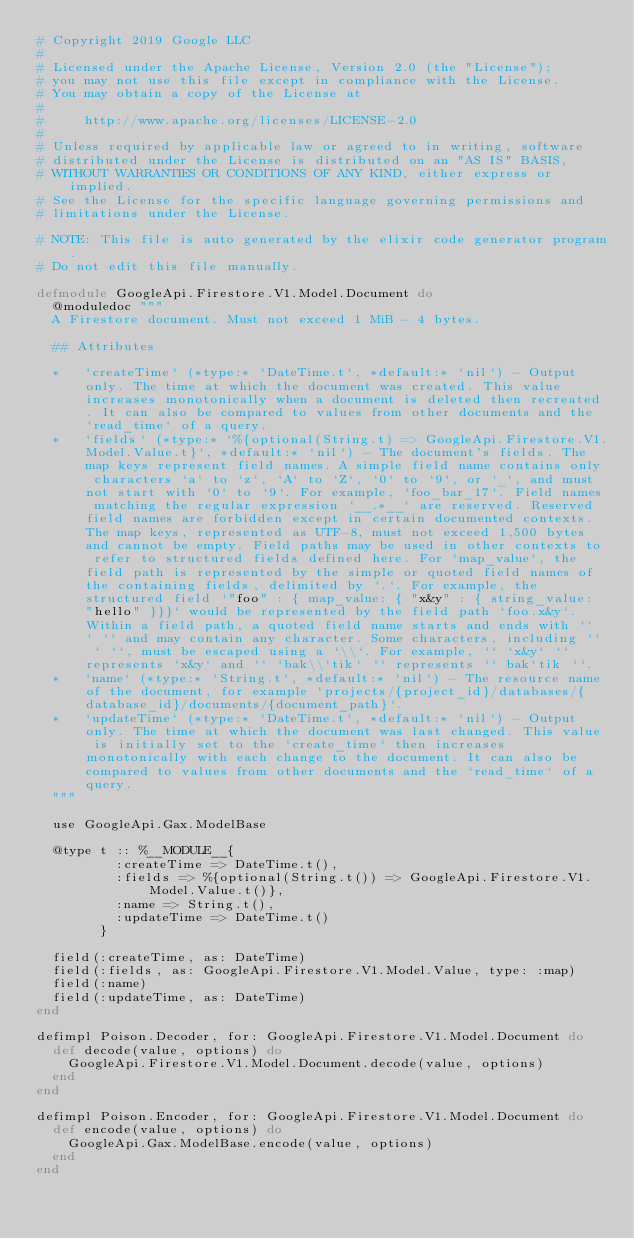Convert code to text. <code><loc_0><loc_0><loc_500><loc_500><_Elixir_># Copyright 2019 Google LLC
#
# Licensed under the Apache License, Version 2.0 (the "License");
# you may not use this file except in compliance with the License.
# You may obtain a copy of the License at
#
#     http://www.apache.org/licenses/LICENSE-2.0
#
# Unless required by applicable law or agreed to in writing, software
# distributed under the License is distributed on an "AS IS" BASIS,
# WITHOUT WARRANTIES OR CONDITIONS OF ANY KIND, either express or implied.
# See the License for the specific language governing permissions and
# limitations under the License.

# NOTE: This file is auto generated by the elixir code generator program.
# Do not edit this file manually.

defmodule GoogleApi.Firestore.V1.Model.Document do
  @moduledoc """
  A Firestore document. Must not exceed 1 MiB - 4 bytes.

  ## Attributes

  *   `createTime` (*type:* `DateTime.t`, *default:* `nil`) - Output only. The time at which the document was created. This value increases monotonically when a document is deleted then recreated. It can also be compared to values from other documents and the `read_time` of a query.
  *   `fields` (*type:* `%{optional(String.t) => GoogleApi.Firestore.V1.Model.Value.t}`, *default:* `nil`) - The document's fields. The map keys represent field names. A simple field name contains only characters `a` to `z`, `A` to `Z`, `0` to `9`, or `_`, and must not start with `0` to `9`. For example, `foo_bar_17`. Field names matching the regular expression `__.*__` are reserved. Reserved field names are forbidden except in certain documented contexts. The map keys, represented as UTF-8, must not exceed 1,500 bytes and cannot be empty. Field paths may be used in other contexts to refer to structured fields defined here. For `map_value`, the field path is represented by the simple or quoted field names of the containing fields, delimited by `.`. For example, the structured field `"foo" : { map_value: { "x&y" : { string_value: "hello" }}}` would be represented by the field path `foo.x&y`. Within a field path, a quoted field name starts and ends with `` ` `` and may contain any character. Some characters, including `` ` ``, must be escaped using a `\\`. For example, `` `x&y` `` represents `x&y` and `` `bak\\`tik` `` represents `` bak`tik ``.
  *   `name` (*type:* `String.t`, *default:* `nil`) - The resource name of the document, for example `projects/{project_id}/databases/{database_id}/documents/{document_path}`.
  *   `updateTime` (*type:* `DateTime.t`, *default:* `nil`) - Output only. The time at which the document was last changed. This value is initially set to the `create_time` then increases monotonically with each change to the document. It can also be compared to values from other documents and the `read_time` of a query.
  """

  use GoogleApi.Gax.ModelBase

  @type t :: %__MODULE__{
          :createTime => DateTime.t(),
          :fields => %{optional(String.t()) => GoogleApi.Firestore.V1.Model.Value.t()},
          :name => String.t(),
          :updateTime => DateTime.t()
        }

  field(:createTime, as: DateTime)
  field(:fields, as: GoogleApi.Firestore.V1.Model.Value, type: :map)
  field(:name)
  field(:updateTime, as: DateTime)
end

defimpl Poison.Decoder, for: GoogleApi.Firestore.V1.Model.Document do
  def decode(value, options) do
    GoogleApi.Firestore.V1.Model.Document.decode(value, options)
  end
end

defimpl Poison.Encoder, for: GoogleApi.Firestore.V1.Model.Document do
  def encode(value, options) do
    GoogleApi.Gax.ModelBase.encode(value, options)
  end
end
</code> 